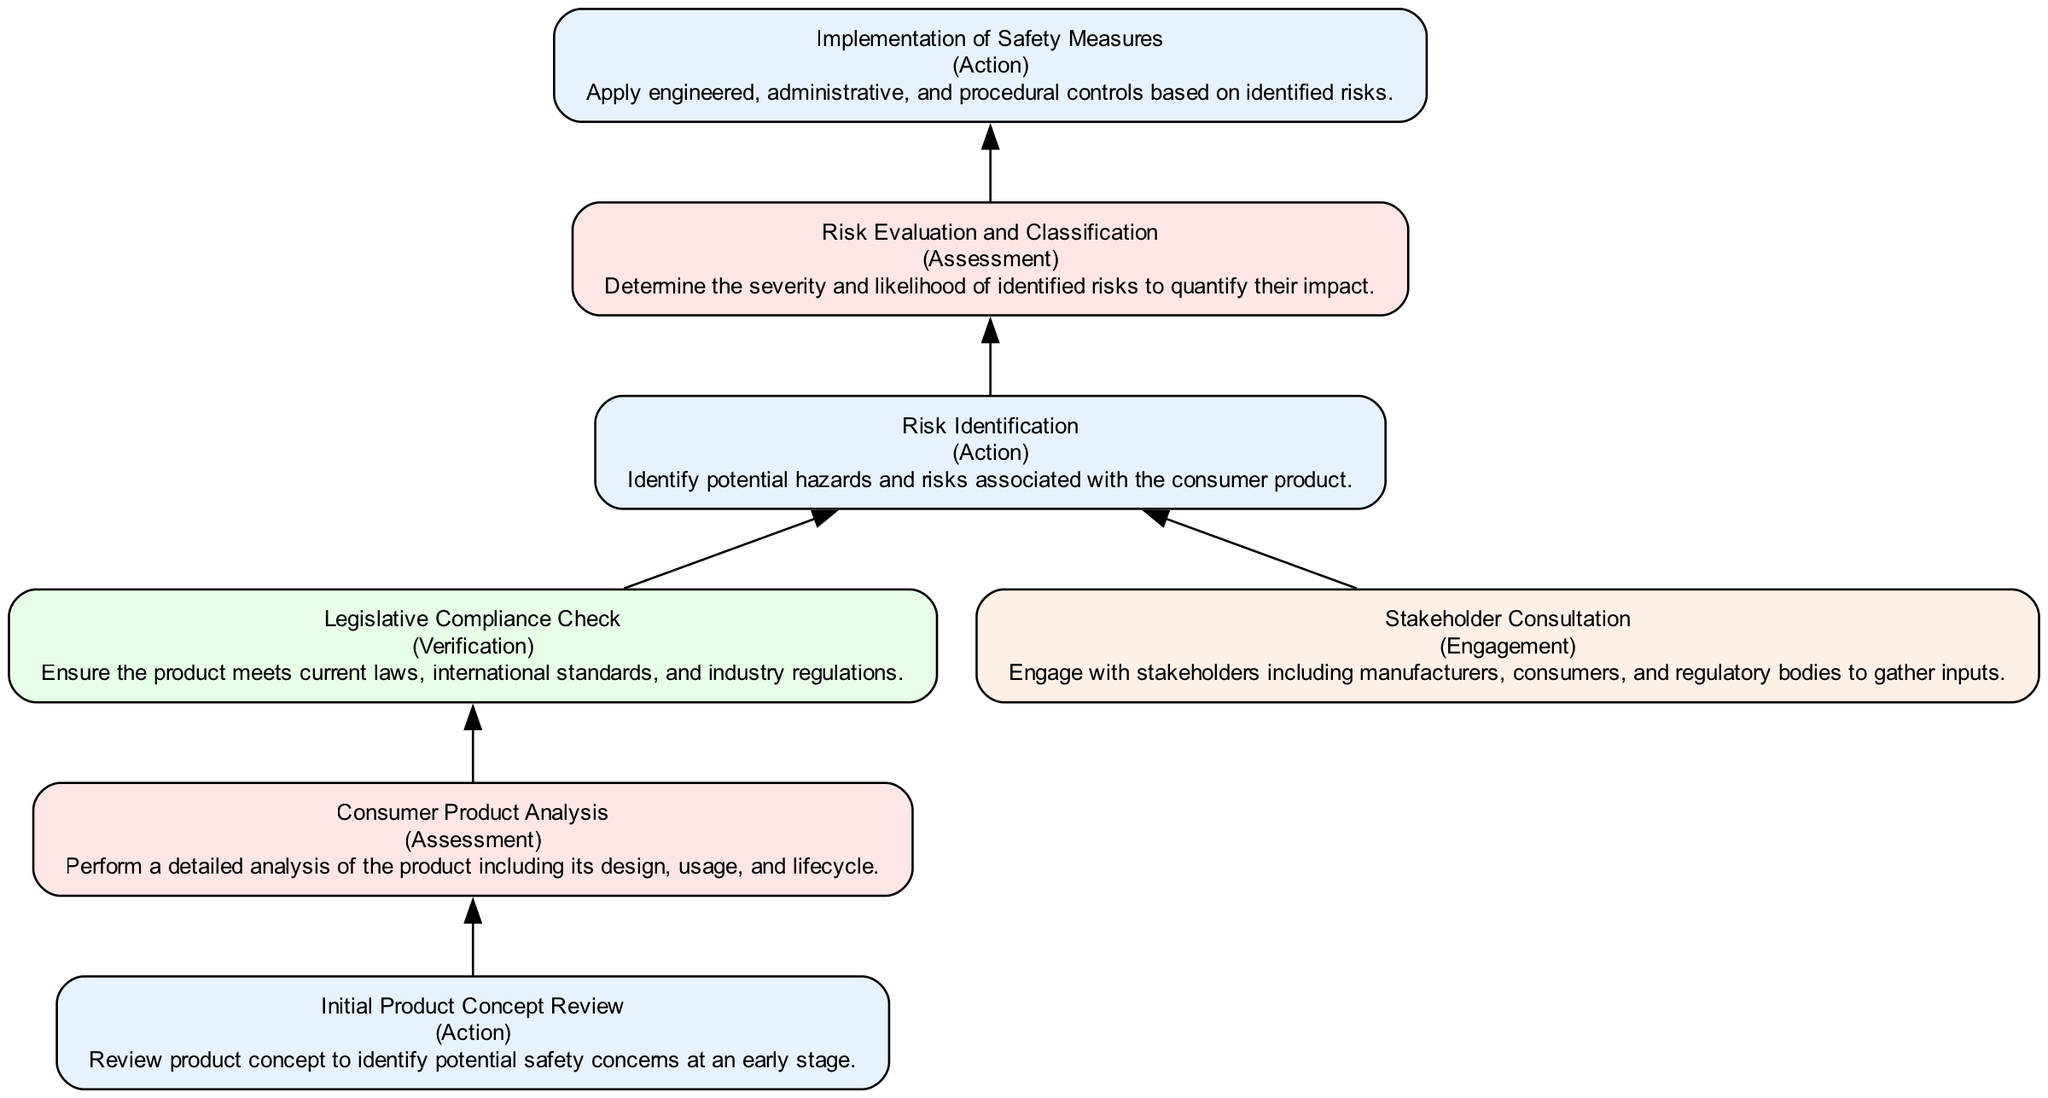What is the first action in the flow? The first action at the bottom of the flowchart is "Initial Product Concept Review." This can be identified as it appears first in the upward flow of actions that lead to the final implementation stages.
Answer: Initial Product Concept Review How many types of elements are in the diagram? The diagram contains four types of elements: Action, Assessment, Verification, and Engagement. Each type is visually differentiated by its respective color according to the semantic category it represents.
Answer: Four What follows "Consumer Product Analysis"? After "Consumer Product Analysis," the next step in the flow is "Legislative Compliance Check." This is indicated by the connecting arrow that directs from the analysis to the compliance check.
Answer: Legislative Compliance Check What is the last step in the risk assessment process? The last step in the risk assessment process is "Implementation of Safety Measures." This is the final action in the upward flow that follows the evaluation and classification of risks.
Answer: Implementation of Safety Measures What element connects "Stakeholder Consultation" to the risk assessment process? "Stakeholder Consultation" connects to the process through "Risk Identification." This indicates that insights gathered from stakeholders influence the identification of risks in consumer products.
Answer: Risk Identification Which type of element is "Legislative Compliance Check"? "Legislative Compliance Check" is a Verification type element. This can be identified by its color and label in the diagram, indicating its purpose of confirming adherence to necessary laws and standards.
Answer: Verification What are the two actions directly preceding "Implementation of Safety Measures"? The two actions directly preceding "Implementation of Safety Measures" are "Risk Evaluation and Classification" and "Risk Identification." These actions signify important steps that lead to the final implementation.
Answer: Risk Evaluation and Classification, Risk Identification Is "Consumer Product Analysis" an Action or Assessment? "Consumer Product Analysis" is an Assessment type element. It is categorized as such based on its purpose to analyze the product without executing direct actions.
Answer: Assessment What happens to risks after they are identified? After risks are identified, they undergo "Risk Evaluation and Classification." This implies a systematic approach to assess the threats identified earlier and determine their severity and likelihood.
Answer: Risk Evaluation and Classification 